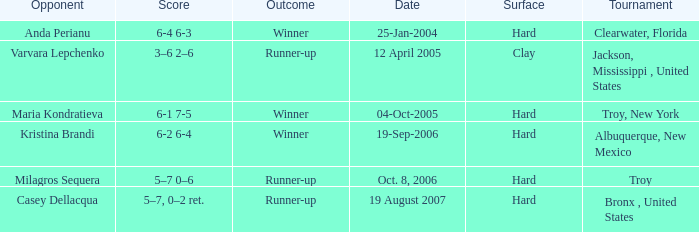What was the outcome of the game played on 19-Sep-2006? Winner. 